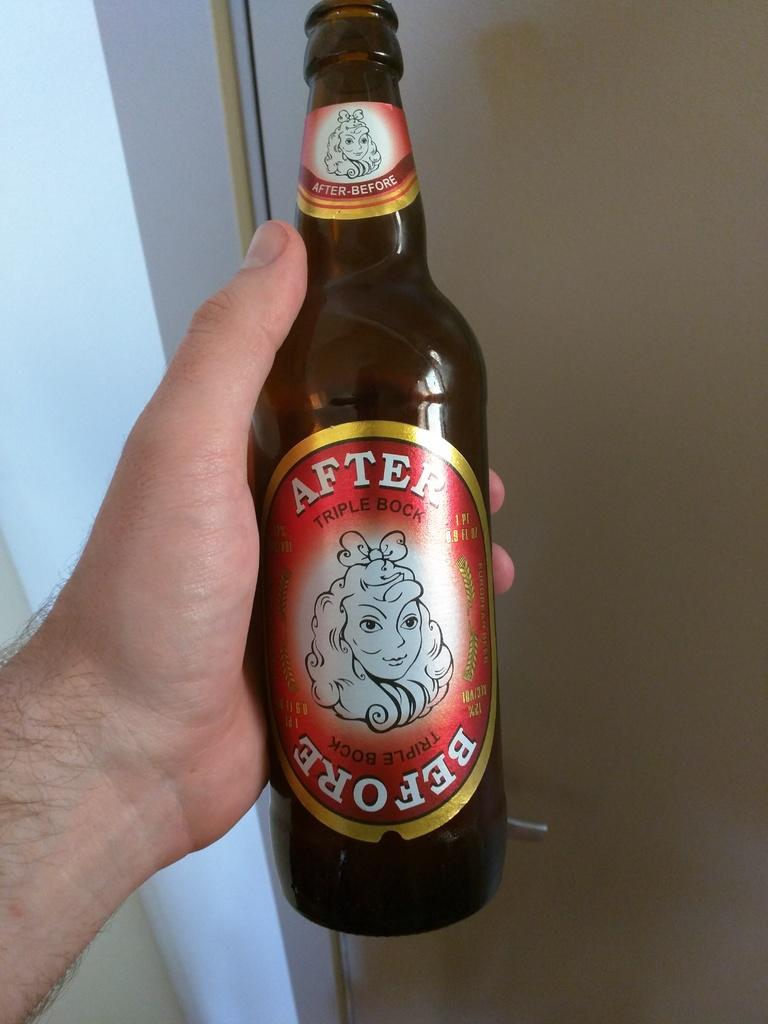<image>
Give a short and clear explanation of the subsequent image. a bottle of beer with the word After written on the top 